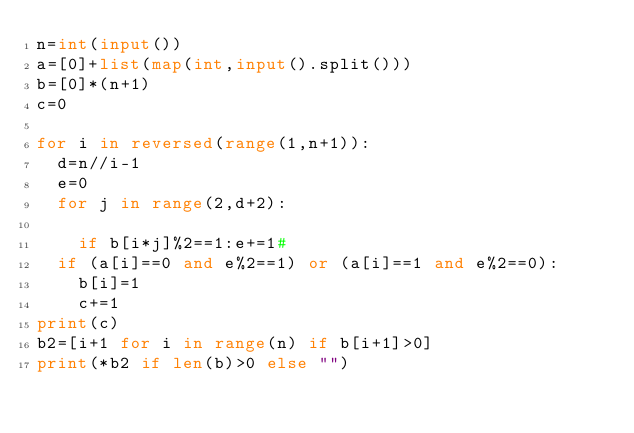<code> <loc_0><loc_0><loc_500><loc_500><_Python_>n=int(input())
a=[0]+list(map(int,input().split()))
b=[0]*(n+1)
c=0

for i in reversed(range(1,n+1)):
  d=n//i-1
  e=0
  for j in range(2,d+2):
    
    if b[i*j]%2==1:e+=1#
  if (a[i]==0 and e%2==1) or (a[i]==1 and e%2==0):
    b[i]=1
    c+=1
print(c)
b2=[i+1 for i in range(n) if b[i+1]>0]
print(*b2 if len(b)>0 else "")
    
    </code> 